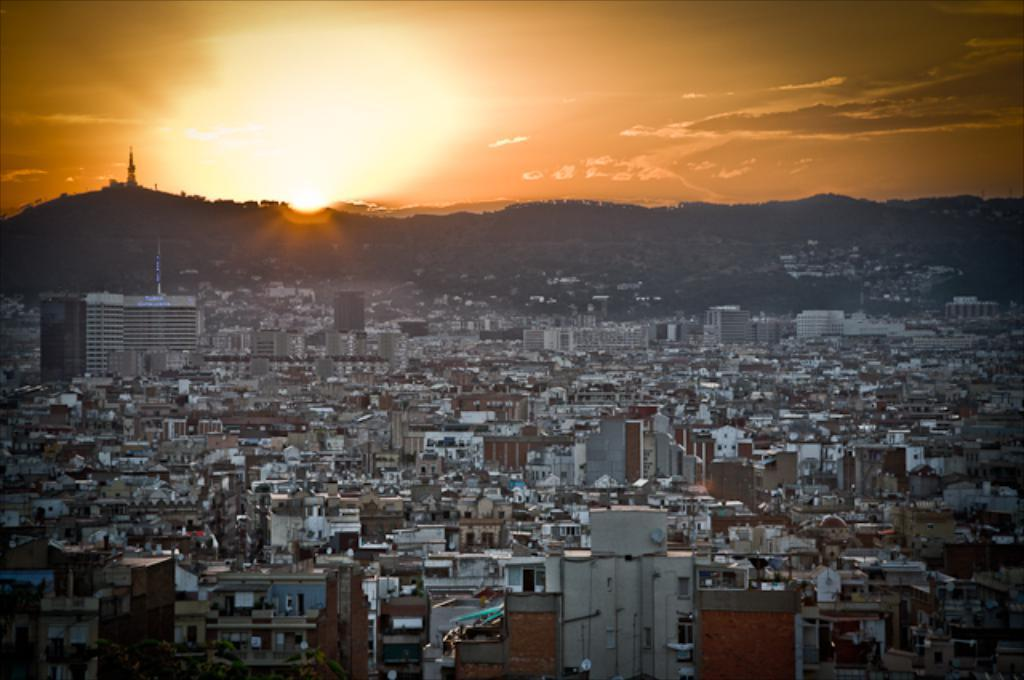What type of structures are located at the bottom of the image? There are many buildings at the bottom of the image. What can be seen in the distance in the image? There are hills in the background of the image. What is visible at the top of the image? The sky is visible at the top of the image. What celestial body is present in the sky? The sun is present in the sky. How many toys are visible on the hills in the image? There are no toys visible on the hills in the image; only buildings, hills, and the sky are present. What type of feet can be seen walking on the buildings in the image? There are no feet visible in the image; it is a landscape image with no people or animals present. 